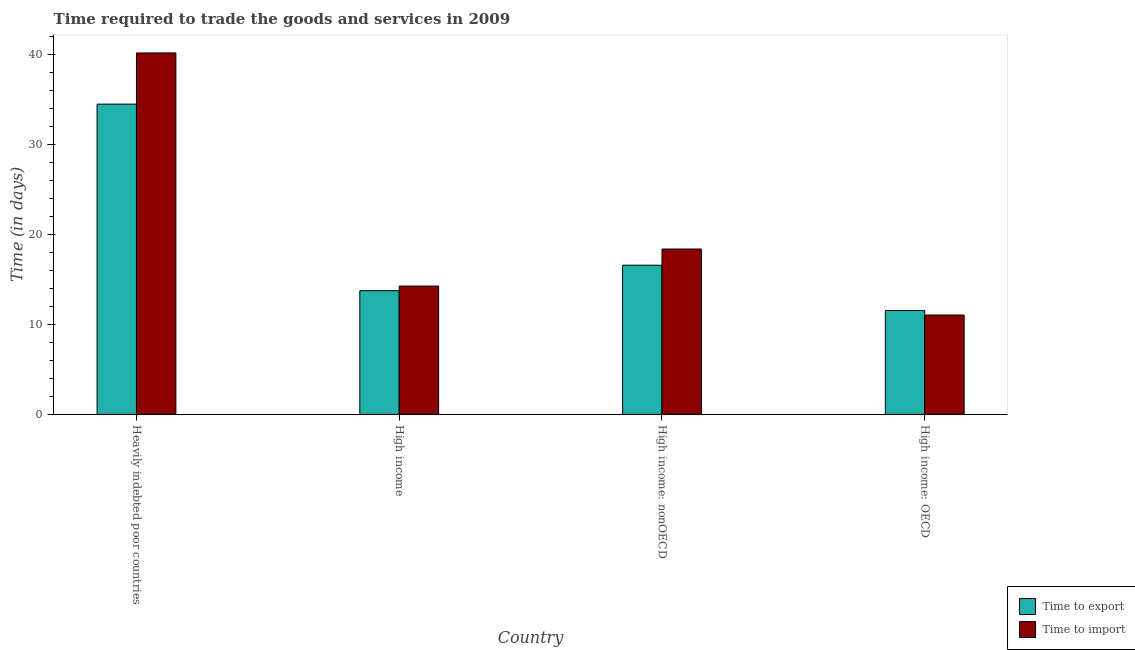How many different coloured bars are there?
Provide a succinct answer. 2. Are the number of bars per tick equal to the number of legend labels?
Your answer should be very brief. Yes. How many bars are there on the 4th tick from the left?
Your answer should be compact. 2. How many bars are there on the 4th tick from the right?
Make the answer very short. 2. What is the label of the 3rd group of bars from the left?
Your answer should be very brief. High income: nonOECD. What is the time to import in High income: OECD?
Provide a short and direct response. 11.03. Across all countries, what is the maximum time to import?
Your response must be concise. 40.13. Across all countries, what is the minimum time to export?
Make the answer very short. 11.53. In which country was the time to import maximum?
Provide a succinct answer. Heavily indebted poor countries. In which country was the time to import minimum?
Provide a short and direct response. High income: OECD. What is the total time to export in the graph?
Your answer should be compact. 76.28. What is the difference between the time to export in Heavily indebted poor countries and that in High income: OECD?
Offer a terse response. 22.92. What is the difference between the time to export in High income: OECD and the time to import in High income?
Offer a very short reply. -2.71. What is the average time to import per country?
Give a very brief answer. 20.94. What is the difference between the time to import and time to export in High income?
Give a very brief answer. 0.51. What is the ratio of the time to import in High income: OECD to that in High income: nonOECD?
Your answer should be compact. 0.6. Is the time to export in High income: OECD less than that in High income: nonOECD?
Your answer should be compact. Yes. Is the difference between the time to import in High income and High income: nonOECD greater than the difference between the time to export in High income and High income: nonOECD?
Your response must be concise. No. What is the difference between the highest and the second highest time to import?
Provide a succinct answer. 21.77. What is the difference between the highest and the lowest time to import?
Your answer should be compact. 29.1. In how many countries, is the time to import greater than the average time to import taken over all countries?
Make the answer very short. 1. Is the sum of the time to export in High income and High income: nonOECD greater than the maximum time to import across all countries?
Keep it short and to the point. No. What does the 2nd bar from the left in Heavily indebted poor countries represents?
Your answer should be very brief. Time to import. What does the 1st bar from the right in Heavily indebted poor countries represents?
Keep it short and to the point. Time to import. What is the difference between two consecutive major ticks on the Y-axis?
Give a very brief answer. 10. What is the title of the graph?
Provide a succinct answer. Time required to trade the goods and services in 2009. Does "Imports" appear as one of the legend labels in the graph?
Provide a succinct answer. No. What is the label or title of the Y-axis?
Your answer should be very brief. Time (in days). What is the Time (in days) of Time to export in Heavily indebted poor countries?
Offer a terse response. 34.45. What is the Time (in days) of Time to import in Heavily indebted poor countries?
Your response must be concise. 40.13. What is the Time (in days) in Time to export in High income?
Ensure brevity in your answer.  13.74. What is the Time (in days) in Time to import in High income?
Your response must be concise. 14.25. What is the Time (in days) of Time to export in High income: nonOECD?
Your answer should be compact. 16.56. What is the Time (in days) in Time to import in High income: nonOECD?
Provide a succinct answer. 18.36. What is the Time (in days) of Time to export in High income: OECD?
Give a very brief answer. 11.53. What is the Time (in days) of Time to import in High income: OECD?
Make the answer very short. 11.03. Across all countries, what is the maximum Time (in days) of Time to export?
Offer a terse response. 34.45. Across all countries, what is the maximum Time (in days) in Time to import?
Offer a terse response. 40.13. Across all countries, what is the minimum Time (in days) of Time to export?
Your answer should be compact. 11.53. Across all countries, what is the minimum Time (in days) of Time to import?
Offer a very short reply. 11.03. What is the total Time (in days) of Time to export in the graph?
Your answer should be compact. 76.28. What is the total Time (in days) in Time to import in the graph?
Your answer should be compact. 83.77. What is the difference between the Time (in days) in Time to export in Heavily indebted poor countries and that in High income?
Keep it short and to the point. 20.71. What is the difference between the Time (in days) in Time to import in Heavily indebted poor countries and that in High income?
Offer a very short reply. 25.89. What is the difference between the Time (in days) of Time to export in Heavily indebted poor countries and that in High income: nonOECD?
Your answer should be compact. 17.89. What is the difference between the Time (in days) of Time to import in Heavily indebted poor countries and that in High income: nonOECD?
Your answer should be compact. 21.77. What is the difference between the Time (in days) in Time to export in Heavily indebted poor countries and that in High income: OECD?
Make the answer very short. 22.92. What is the difference between the Time (in days) of Time to import in Heavily indebted poor countries and that in High income: OECD?
Make the answer very short. 29.1. What is the difference between the Time (in days) in Time to export in High income and that in High income: nonOECD?
Provide a succinct answer. -2.82. What is the difference between the Time (in days) of Time to import in High income and that in High income: nonOECD?
Your response must be concise. -4.11. What is the difference between the Time (in days) of Time to export in High income and that in High income: OECD?
Make the answer very short. 2.21. What is the difference between the Time (in days) of Time to import in High income and that in High income: OECD?
Offer a terse response. 3.21. What is the difference between the Time (in days) in Time to export in High income: nonOECD and that in High income: OECD?
Your answer should be compact. 5.03. What is the difference between the Time (in days) in Time to import in High income: nonOECD and that in High income: OECD?
Provide a short and direct response. 7.33. What is the difference between the Time (in days) in Time to export in Heavily indebted poor countries and the Time (in days) in Time to import in High income?
Offer a very short reply. 20.2. What is the difference between the Time (in days) in Time to export in Heavily indebted poor countries and the Time (in days) in Time to import in High income: nonOECD?
Ensure brevity in your answer.  16.09. What is the difference between the Time (in days) in Time to export in Heavily indebted poor countries and the Time (in days) in Time to import in High income: OECD?
Ensure brevity in your answer.  23.42. What is the difference between the Time (in days) in Time to export in High income and the Time (in days) in Time to import in High income: nonOECD?
Offer a terse response. -4.62. What is the difference between the Time (in days) of Time to export in High income and the Time (in days) of Time to import in High income: OECD?
Your response must be concise. 2.71. What is the difference between the Time (in days) in Time to export in High income: nonOECD and the Time (in days) in Time to import in High income: OECD?
Your answer should be very brief. 5.53. What is the average Time (in days) in Time to export per country?
Provide a succinct answer. 19.07. What is the average Time (in days) of Time to import per country?
Provide a succinct answer. 20.94. What is the difference between the Time (in days) of Time to export and Time (in days) of Time to import in Heavily indebted poor countries?
Give a very brief answer. -5.68. What is the difference between the Time (in days) of Time to export and Time (in days) of Time to import in High income?
Ensure brevity in your answer.  -0.51. What is the difference between the Time (in days) in Time to export and Time (in days) in Time to import in High income: nonOECD?
Offer a very short reply. -1.8. What is the difference between the Time (in days) in Time to export and Time (in days) in Time to import in High income: OECD?
Keep it short and to the point. 0.5. What is the ratio of the Time (in days) in Time to export in Heavily indebted poor countries to that in High income?
Provide a short and direct response. 2.51. What is the ratio of the Time (in days) of Time to import in Heavily indebted poor countries to that in High income?
Provide a succinct answer. 2.82. What is the ratio of the Time (in days) in Time to export in Heavily indebted poor countries to that in High income: nonOECD?
Offer a very short reply. 2.08. What is the ratio of the Time (in days) in Time to import in Heavily indebted poor countries to that in High income: nonOECD?
Ensure brevity in your answer.  2.19. What is the ratio of the Time (in days) of Time to export in Heavily indebted poor countries to that in High income: OECD?
Keep it short and to the point. 2.99. What is the ratio of the Time (in days) in Time to import in Heavily indebted poor countries to that in High income: OECD?
Offer a very short reply. 3.64. What is the ratio of the Time (in days) of Time to export in High income to that in High income: nonOECD?
Provide a succinct answer. 0.83. What is the ratio of the Time (in days) in Time to import in High income to that in High income: nonOECD?
Make the answer very short. 0.78. What is the ratio of the Time (in days) in Time to export in High income to that in High income: OECD?
Your answer should be very brief. 1.19. What is the ratio of the Time (in days) of Time to import in High income to that in High income: OECD?
Ensure brevity in your answer.  1.29. What is the ratio of the Time (in days) of Time to export in High income: nonOECD to that in High income: OECD?
Provide a succinct answer. 1.44. What is the ratio of the Time (in days) of Time to import in High income: nonOECD to that in High income: OECD?
Your answer should be very brief. 1.66. What is the difference between the highest and the second highest Time (in days) of Time to export?
Your answer should be very brief. 17.89. What is the difference between the highest and the second highest Time (in days) of Time to import?
Offer a very short reply. 21.77. What is the difference between the highest and the lowest Time (in days) of Time to export?
Your answer should be compact. 22.92. What is the difference between the highest and the lowest Time (in days) of Time to import?
Your response must be concise. 29.1. 